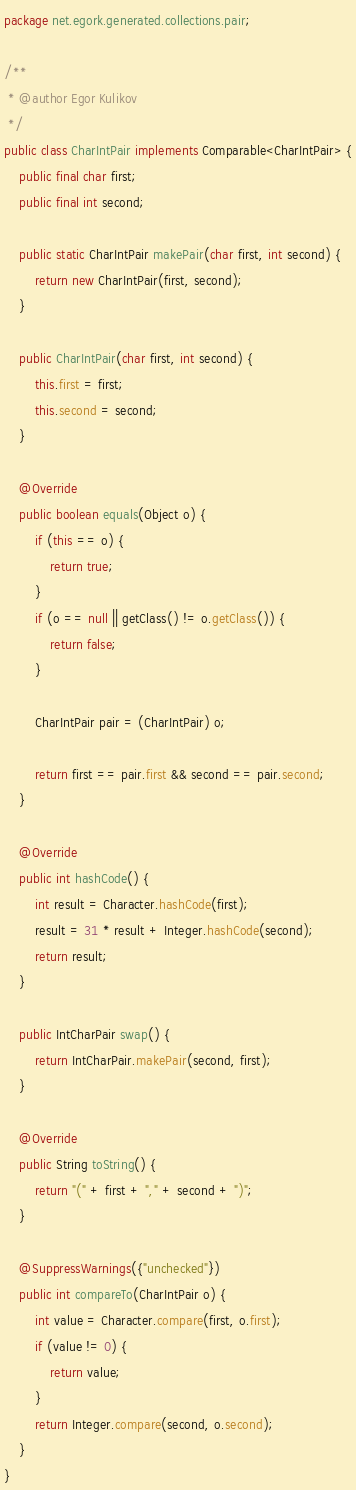Convert code to text. <code><loc_0><loc_0><loc_500><loc_500><_Java_>package net.egork.generated.collections.pair;

/**
 * @author Egor Kulikov
 */
public class CharIntPair implements Comparable<CharIntPair> {
    public final char first;
    public final int second;

    public static CharIntPair makePair(char first, int second) {
        return new CharIntPair(first, second);
    }

    public CharIntPair(char first, int second) {
        this.first = first;
        this.second = second;
    }

    @Override
    public boolean equals(Object o) {
        if (this == o) {
            return true;
        }
        if (o == null || getClass() != o.getClass()) {
            return false;
        }

        CharIntPair pair = (CharIntPair) o;

        return first == pair.first && second == pair.second;
    }

    @Override
    public int hashCode() {
        int result = Character.hashCode(first);
        result = 31 * result + Integer.hashCode(second);
        return result;
    }

    public IntCharPair swap() {
        return IntCharPair.makePair(second, first);
    }

    @Override
    public String toString() {
        return "(" + first + "," + second + ")";
    }

    @SuppressWarnings({"unchecked"})
    public int compareTo(CharIntPair o) {
        int value = Character.compare(first, o.first);
        if (value != 0) {
            return value;
        }
        return Integer.compare(second, o.second);
    }
}
</code> 